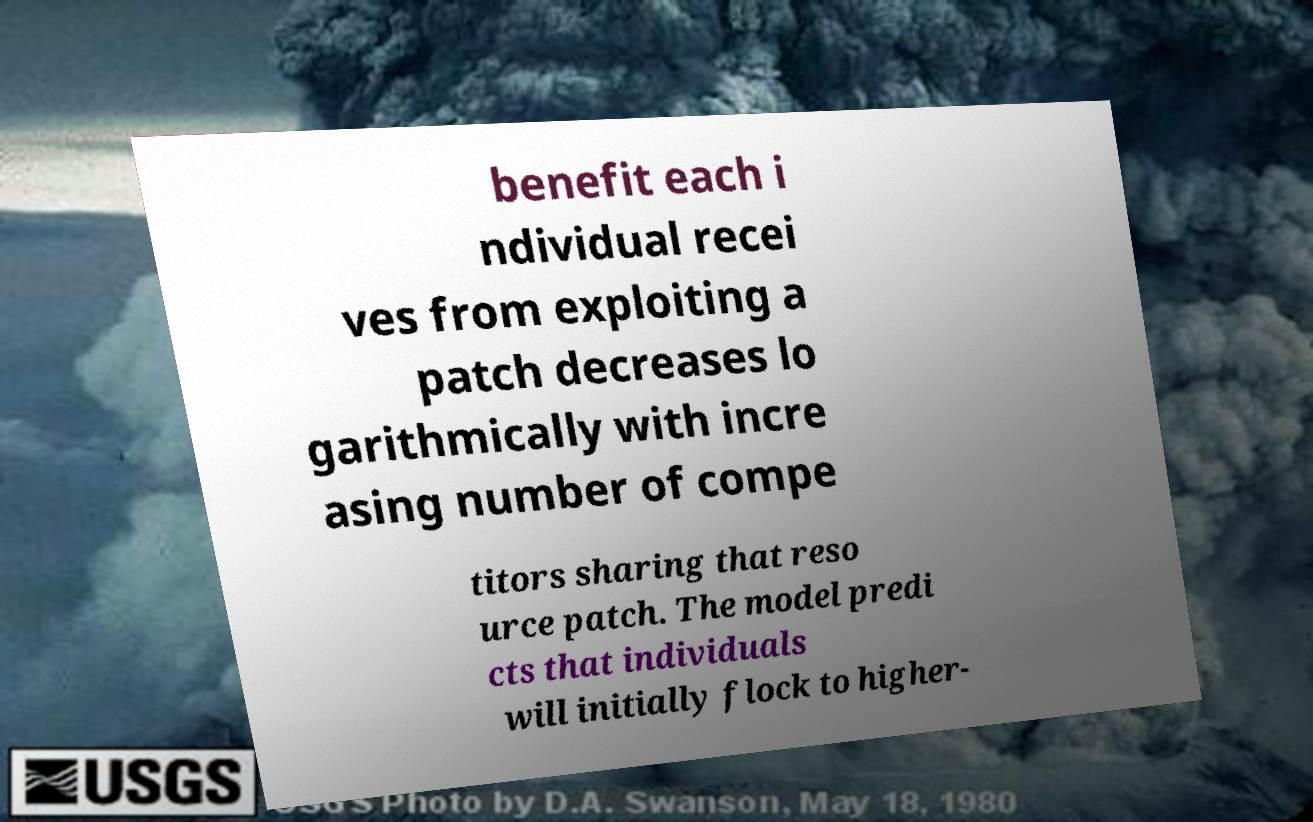Could you assist in decoding the text presented in this image and type it out clearly? benefit each i ndividual recei ves from exploiting a patch decreases lo garithmically with incre asing number of compe titors sharing that reso urce patch. The model predi cts that individuals will initially flock to higher- 